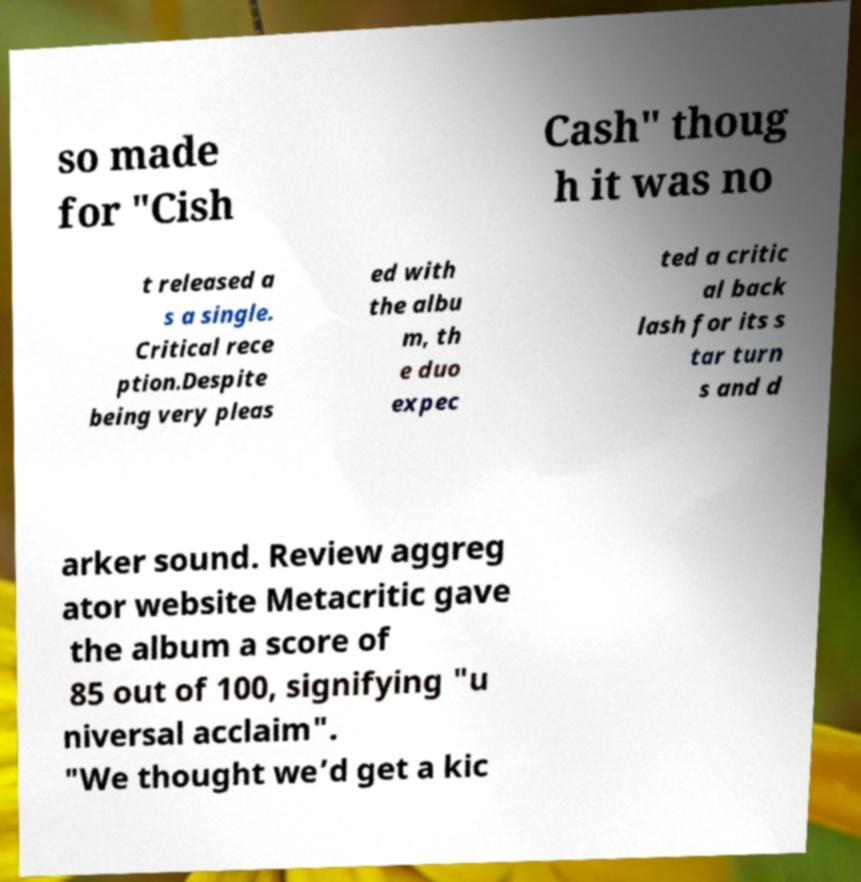For documentation purposes, I need the text within this image transcribed. Could you provide that? so made for "Cish Cash" thoug h it was no t released a s a single. Critical rece ption.Despite being very pleas ed with the albu m, th e duo expec ted a critic al back lash for its s tar turn s and d arker sound. Review aggreg ator website Metacritic gave the album a score of 85 out of 100, signifying "u niversal acclaim". "We thought we’d get a kic 